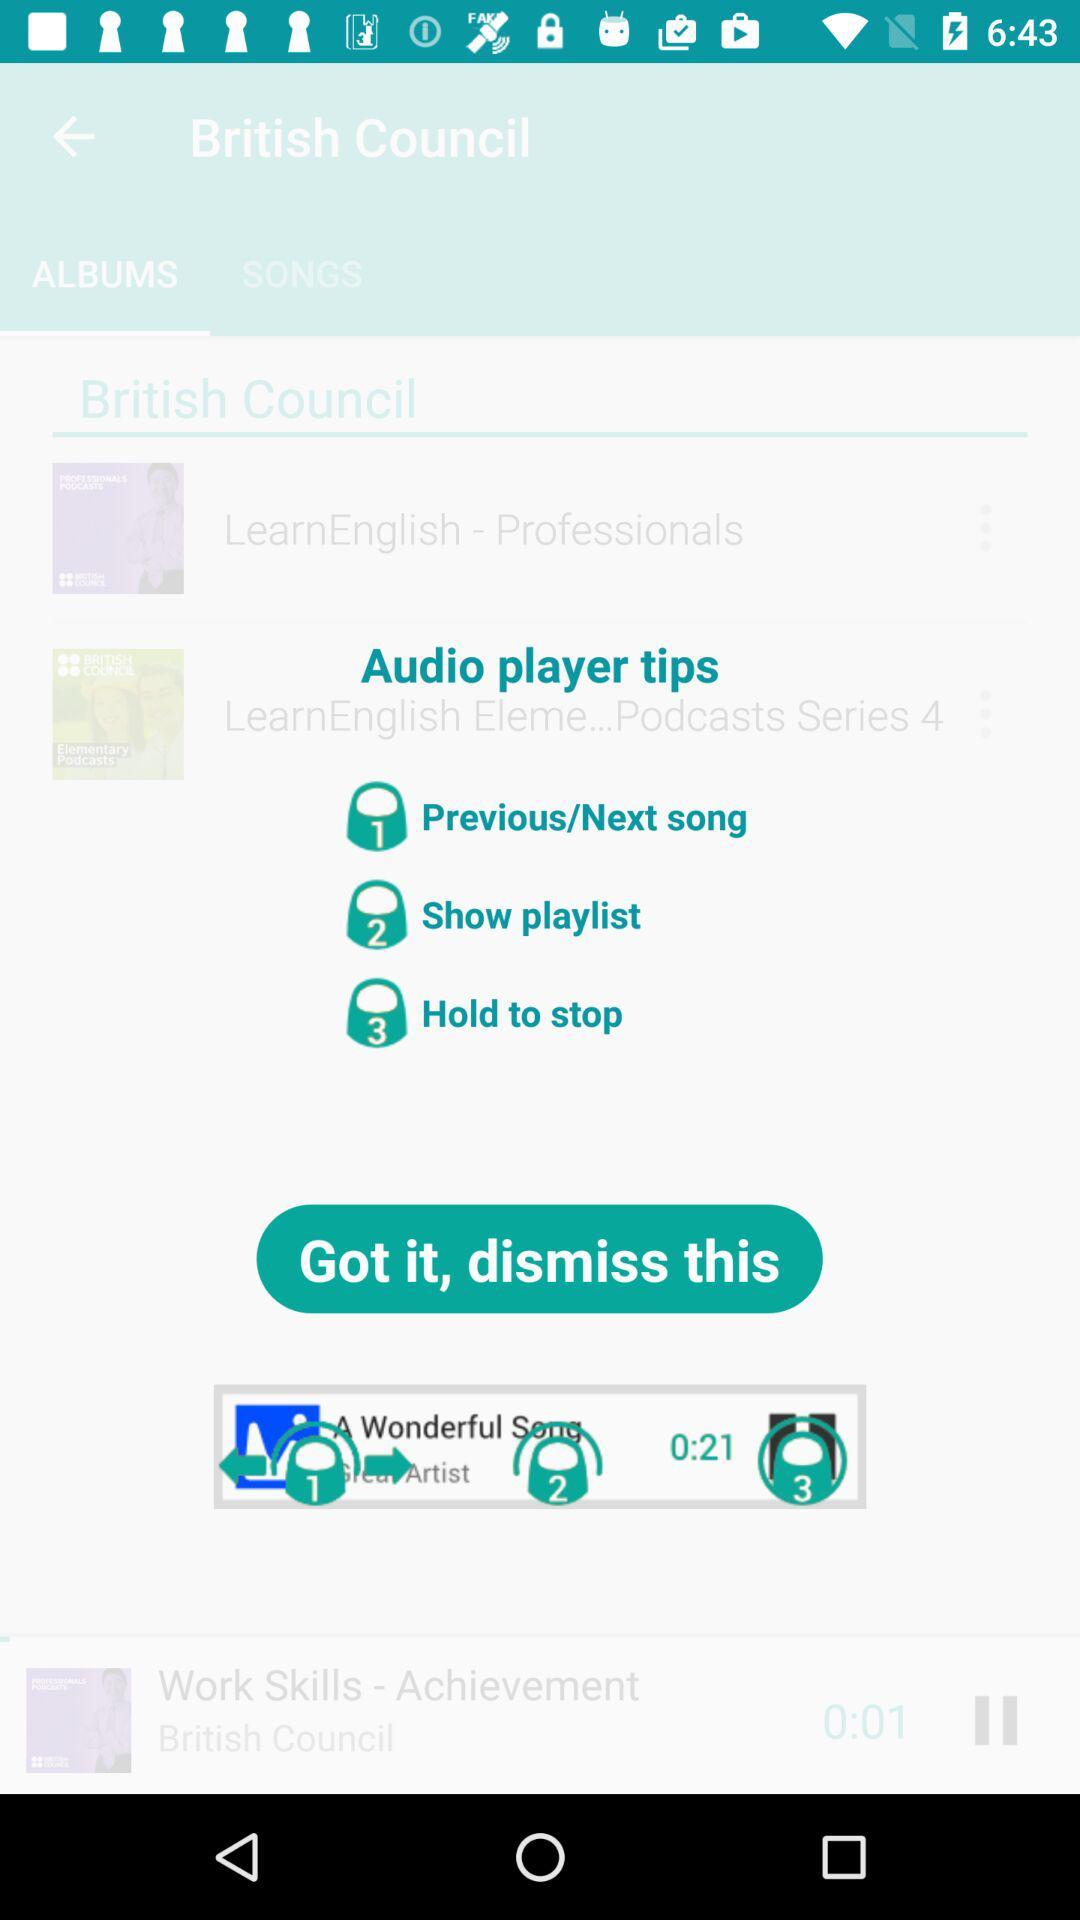How long is the current song in seconds?
Answer the question using a single word or phrase. 0:21 